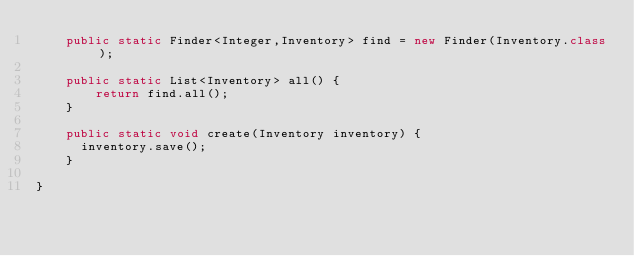<code> <loc_0><loc_0><loc_500><loc_500><_Java_>	public static Finder<Integer,Inventory> find = new Finder(Inventory.class);
	
	public static List<Inventory> all() {
		return find.all();
	}

	public static void create(Inventory inventory) {
	  inventory.save();
	}
  
}
</code> 